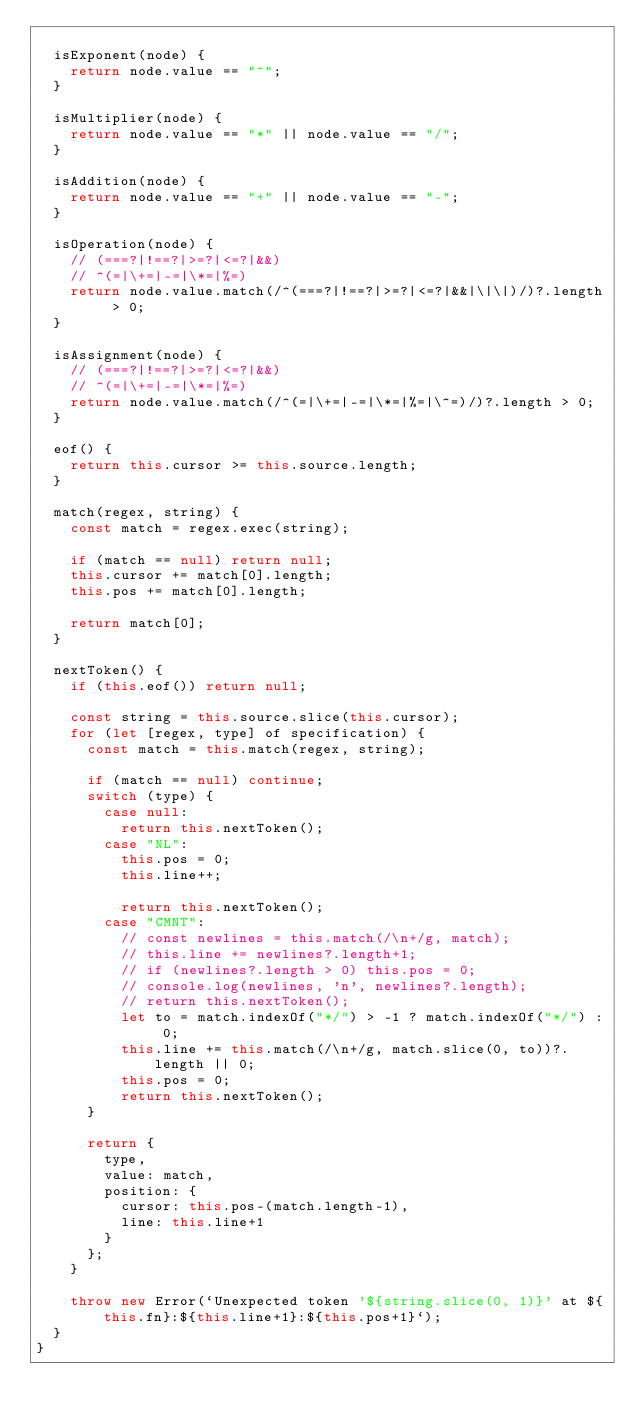Convert code to text. <code><loc_0><loc_0><loc_500><loc_500><_JavaScript_>
	isExponent(node) {
		return node.value == "^";
	}

	isMultiplier(node) {
		return node.value == "*" || node.value == "/";
	}
	
	isAddition(node) {
		return node.value == "+" || node.value == "-";
	}

	isOperation(node) {
		// (===?|!==?|>=?|<=?|&&)
		// ^(=|\+=|-=|\*=|%=)
		return node.value.match(/^(===?|!==?|>=?|<=?|&&|\|\|)/)?.length > 0;
	}

	isAssignment(node) {
		// (===?|!==?|>=?|<=?|&&)
		// ^(=|\+=|-=|\*=|%=)
		return node.value.match(/^(=|\+=|-=|\*=|%=|\^=)/)?.length > 0;
	}

	eof() {
		return this.cursor >= this.source.length;
	}

	match(regex, string) {
		const match = regex.exec(string);

		if (match == null) return null;
		this.cursor += match[0].length;
		this.pos += match[0].length;

		return match[0];
	}

	nextToken() {
		if (this.eof()) return null;
		
		const string = this.source.slice(this.cursor);
		for (let [regex, type] of specification) {
			const match = this.match(regex, string);

			if (match == null) continue;
			switch (type) {
				case null:
					return this.nextToken();
				case "NL":
					this.pos = 0;
					this.line++;

					return this.nextToken();
				case "CMNT":
					// const newlines = this.match(/\n+/g, match);
					// this.line += newlines?.length+1;
					// if (newlines?.length > 0) this.pos = 0;
					// console.log(newlines, 'n', newlines?.length);
					// return this.nextToken();
					let to = match.indexOf("*/") > -1 ? match.indexOf("*/") : 0;
					this.line += this.match(/\n+/g, match.slice(0, to))?.length || 0;
					this.pos = 0;
					return this.nextToken();
			}

			return {
				type,
				value: match,
				position: {
					cursor: this.pos-(match.length-1),
					line: this.line+1
				}
			};
		}

		throw new Error(`Unexpected token '${string.slice(0, 1)}' at ${this.fn}:${this.line+1}:${this.pos+1}`);
	}
}
</code> 